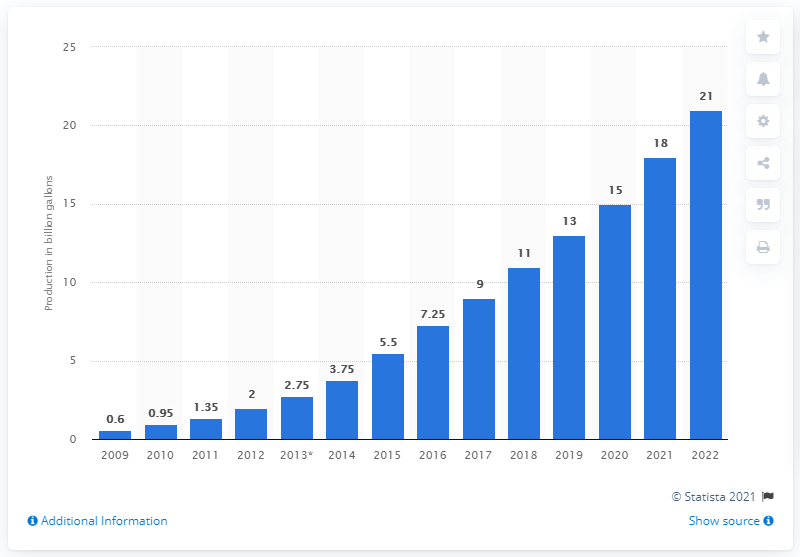Point out several critical features in this image. The United States is expected to produce 21 million units of advanced biofuel in 2022. 